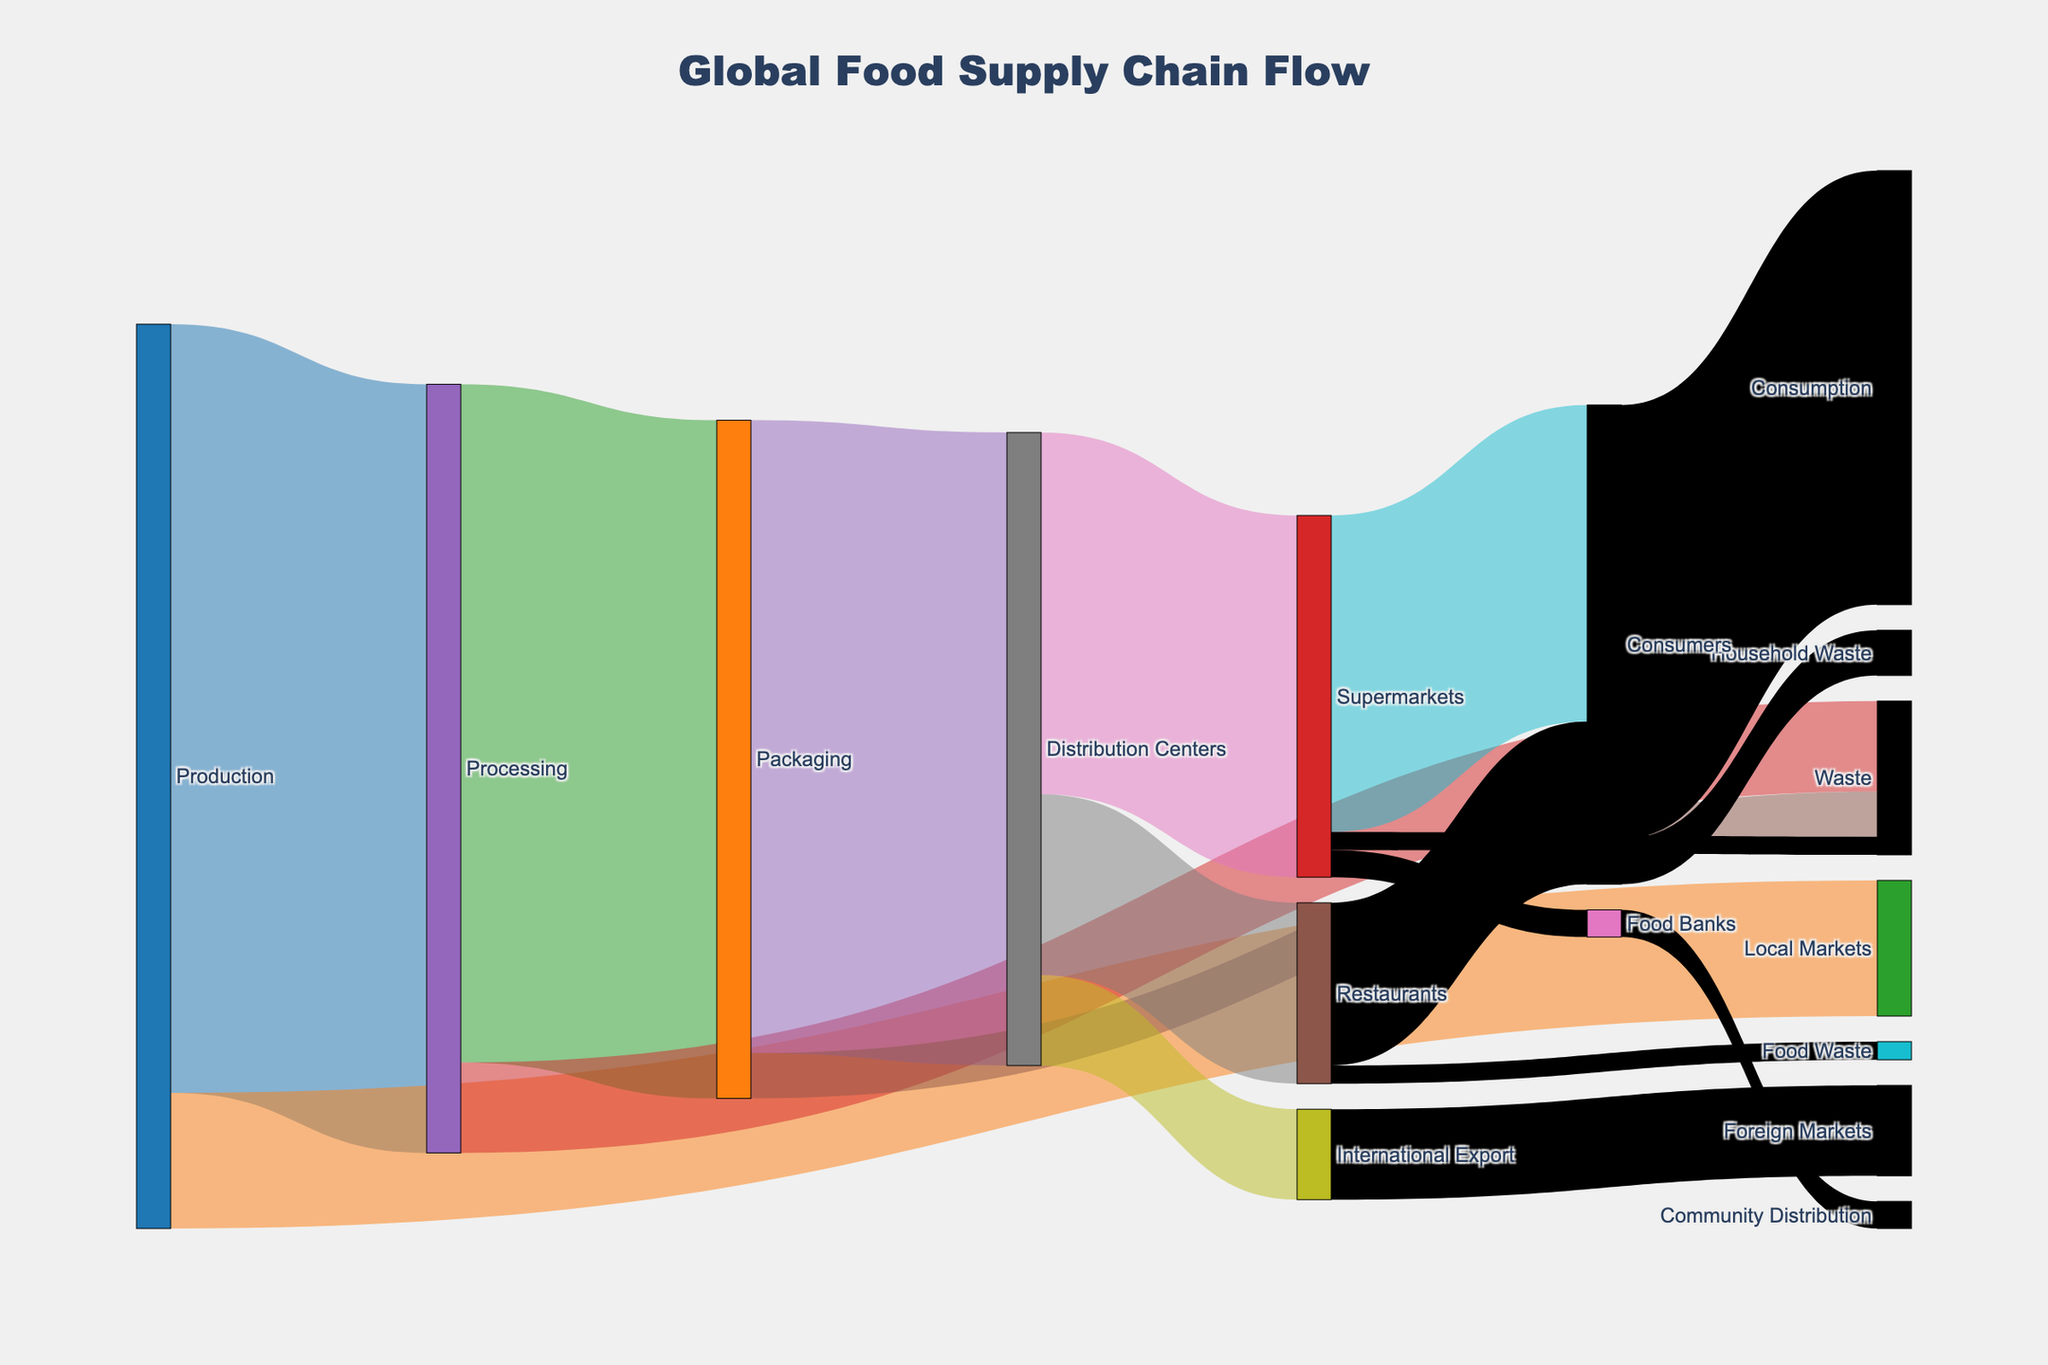What is the main title of the figure? The main title is displayed at the top center of the figure. It reads "Global Food Supply Chain Flow".
Answer: Global Food Supply Chain Flow What color is used to represent the "Production" node? The color representation of each node can be identified by its distinct shade. "Production" is the starting node in blue.
Answer: Blue How many different endpoints are there for "Consumers"? From the "Consumers" node, there are two endpoints: "Consumption" and "Household Waste".
Answer: 2 What is the total quantity of food that ends up in "Waste" from all sources combined? To find the total waste amount, sum all values that end up in "Waste": Processing (10) + Packaging (5) + Supermarkets (2) + Restaurants (2).
Answer: 19 How much food does the "Packaging" process before distributing it to other nodes? Sum the values from "Processing" to "Packaging" (75), and "Packaging" to other nodes (70 + 5) which equals 75 for distribution confirmation.
Answer: 75 Which endpoint receives the smallest quantity of food, and how much does it receive? The endpoint with the smallest quantity can be found by comparing food values at endpoints. Here, "Household Waste" and "Food Waste" each receive 5.
Answer: Household Waste, 5 Which node receives the highest quantity of food directly from "Distribution Centers"? Compare the values: Supermarkets (40), Restaurants (20), International Export (10). "Supermarkets" receive the highest amount.
Answer: Supermarkets Is there any node that functions as both an origin and target (intermediate node)? Identify nodes that both send and receive values. These are "Processing," "Packaging," and "Distribution Centers".
Answer: Processing, Packaging, Distribution Centers What is the difference in food supply between "Consumers" and "Foreign Markets"? Consumers receive 48, and Foreign Markets receive 10 from International Export. The difference is calculated by subtracting 10 from 48.
Answer: 38 How many units of food come from "Food Banks" and where do they go? Food Banks have a single flow of 3 units going to "Community Distribution".
Answer: 3, Community Distribution 